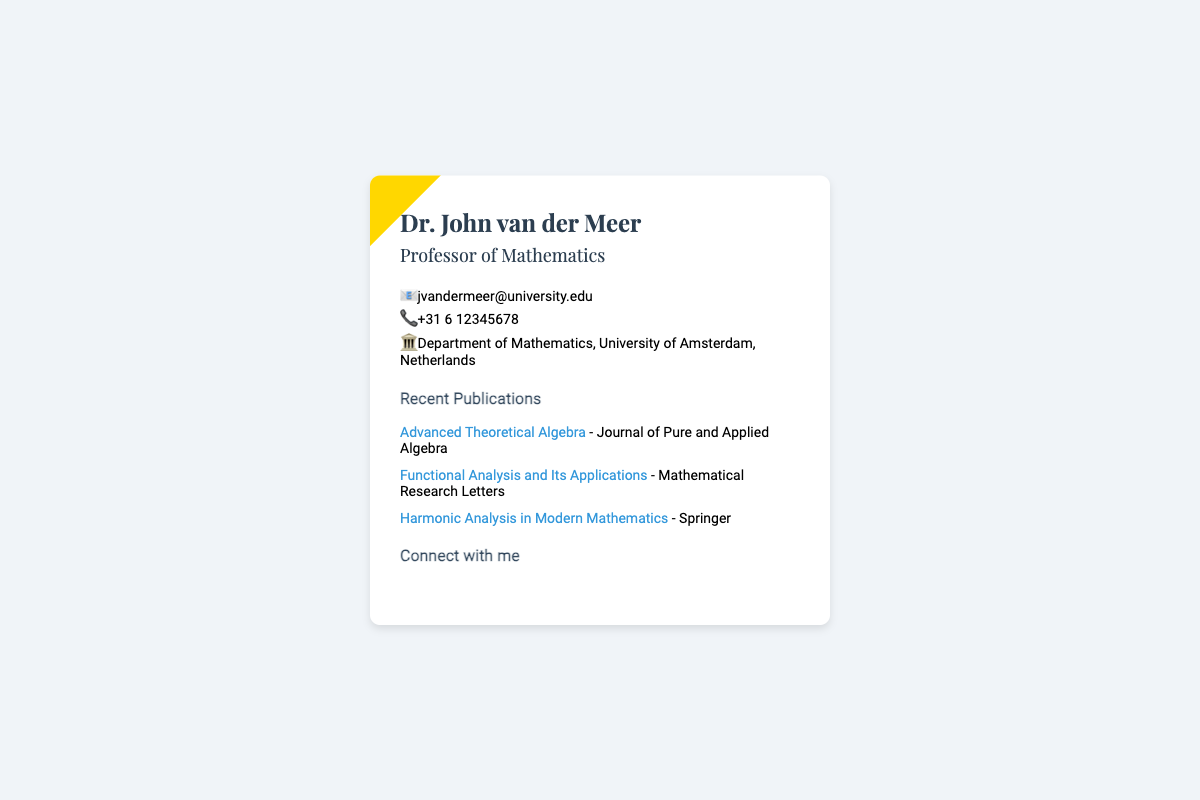What is the name of the professor? The name of the professor is stated at the top of the document as Dr. John van der Meer.
Answer: Dr. John van der Meer What is the professor's email address? The email address is provided in the contact section of the document.
Answer: jvandermeer@university.edu Which university is the professor affiliated with? The university affiliation is mentioned in the contact details.
Answer: University of Amsterdam How many recent publications are listed? The publications section provides a count of the items mentioned; there are three publications listed.
Answer: 3 What is the title of the book published by Springer? The title of the book is presented in the publications list.
Answer: Harmonic Analysis in Modern Mathematics On which platform can you find the professor's LinkedIn profile? The document specifies the platform for the LinkedIn link in the social section.
Answer: LinkedIn What is the primary field of expertise of Dr. John van der Meer? The field of expertise is mentioned in the title following the professor's name.
Answer: Mathematics What type of document is this? The overall structure and content indicate the nature of this item, which is a business card.
Answer: Business card 